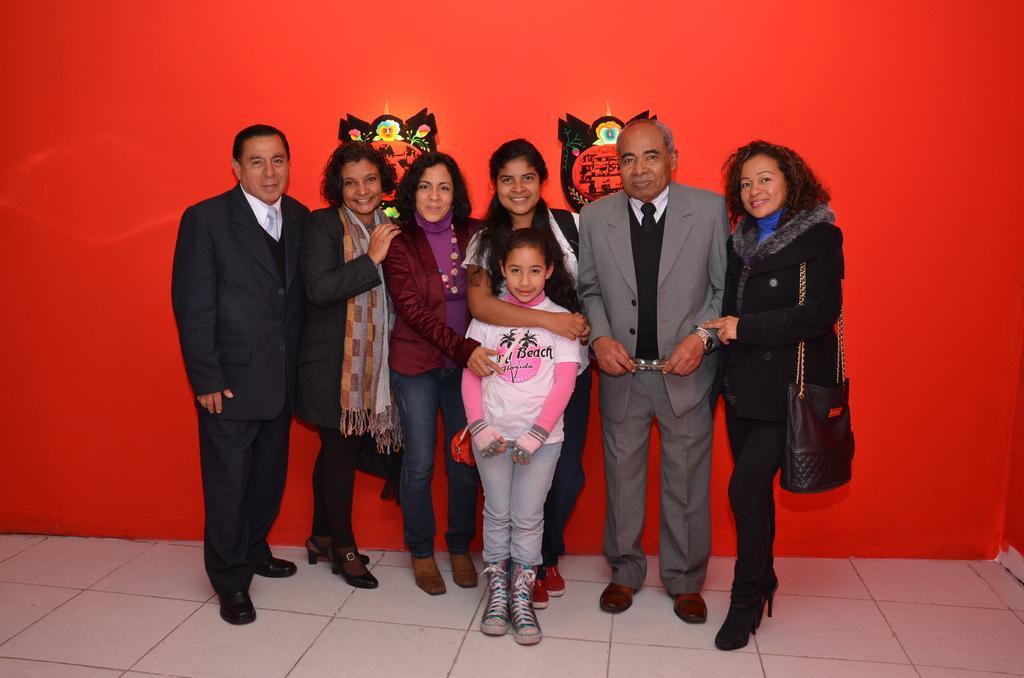How would you summarize this image in a sentence or two? Here there are two men and three women and a girl standing on the floor. In the background there are stickers on the wall. 